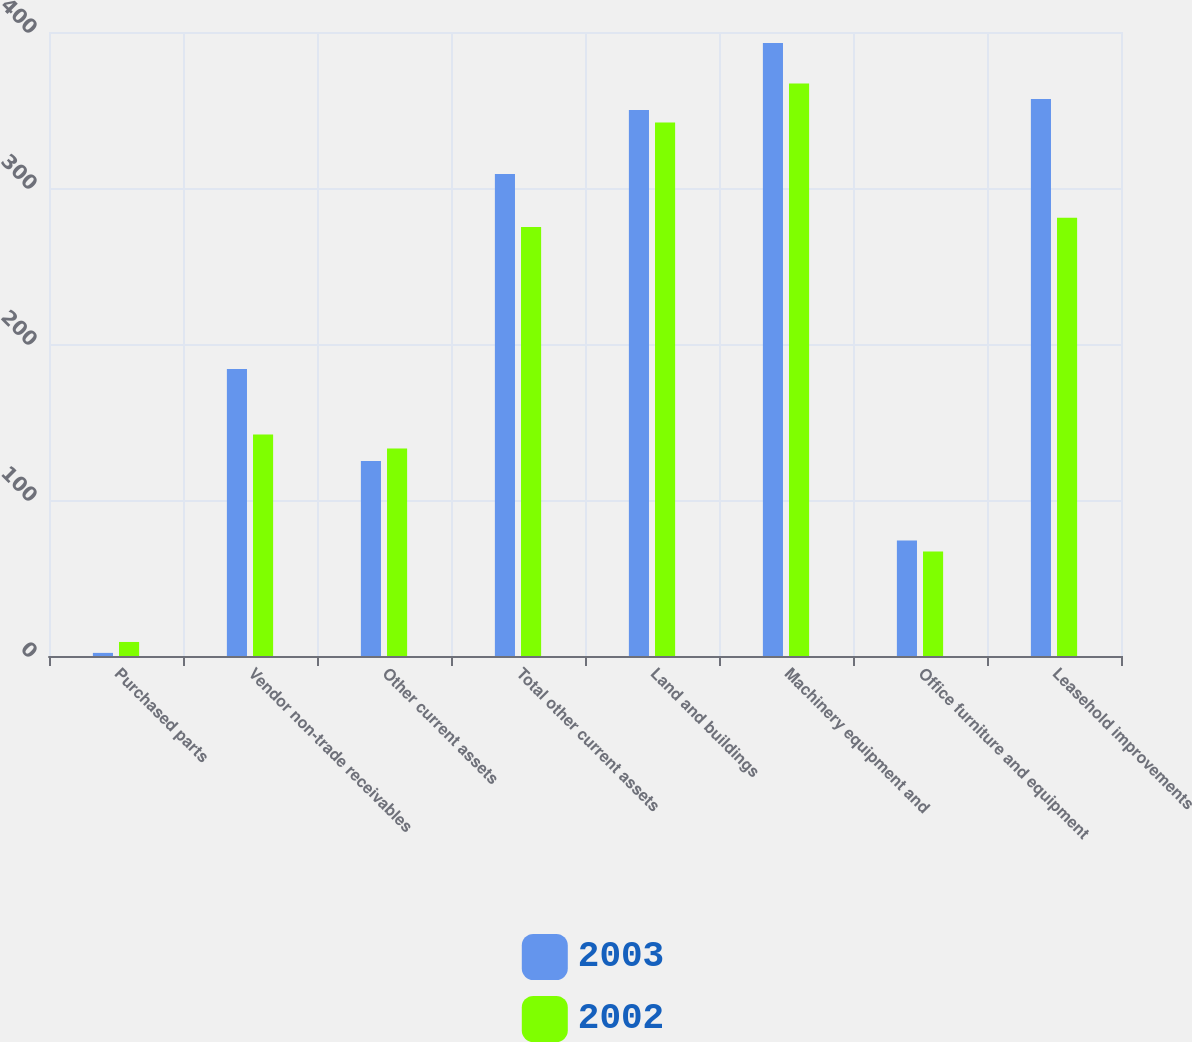Convert chart to OTSL. <chart><loc_0><loc_0><loc_500><loc_500><stacked_bar_chart><ecel><fcel>Purchased parts<fcel>Vendor non-trade receivables<fcel>Other current assets<fcel>Total other current assets<fcel>Land and buildings<fcel>Machinery equipment and<fcel>Office furniture and equipment<fcel>Leasehold improvements<nl><fcel>2003<fcel>2<fcel>184<fcel>125<fcel>309<fcel>350<fcel>393<fcel>74<fcel>357<nl><fcel>2002<fcel>9<fcel>142<fcel>133<fcel>275<fcel>342<fcel>367<fcel>67<fcel>281<nl></chart> 